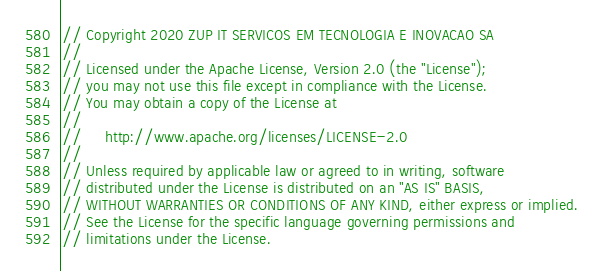Convert code to text. <code><loc_0><loc_0><loc_500><loc_500><_Go_>// Copyright 2020 ZUP IT SERVICOS EM TECNOLOGIA E INOVACAO SA
//
// Licensed under the Apache License, Version 2.0 (the "License");
// you may not use this file except in compliance with the License.
// You may obtain a copy of the License at
//
//     http://www.apache.org/licenses/LICENSE-2.0
//
// Unless required by applicable law or agreed to in writing, software
// distributed under the License is distributed on an "AS IS" BASIS,
// WITHOUT WARRANTIES OR CONDITIONS OF ANY KIND, either express or implied.
// See the License for the specific language governing permissions and
// limitations under the License.
</code> 